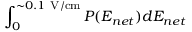<formula> <loc_0><loc_0><loc_500><loc_500>\int _ { 0 } ^ { \sim 0 . 1 { V / c m } } P ( E _ { n e t } ) d E _ { n e t }</formula> 